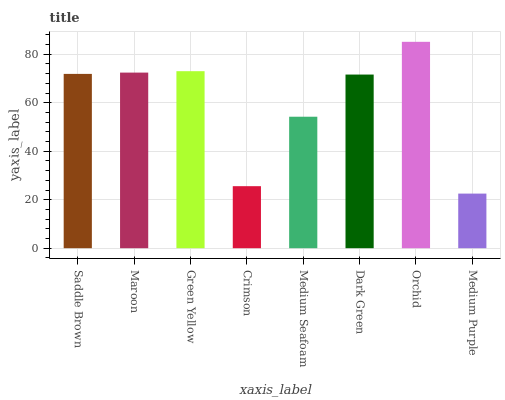Is Medium Purple the minimum?
Answer yes or no. Yes. Is Orchid the maximum?
Answer yes or no. Yes. Is Maroon the minimum?
Answer yes or no. No. Is Maroon the maximum?
Answer yes or no. No. Is Maroon greater than Saddle Brown?
Answer yes or no. Yes. Is Saddle Brown less than Maroon?
Answer yes or no. Yes. Is Saddle Brown greater than Maroon?
Answer yes or no. No. Is Maroon less than Saddle Brown?
Answer yes or no. No. Is Saddle Brown the high median?
Answer yes or no. Yes. Is Dark Green the low median?
Answer yes or no. Yes. Is Dark Green the high median?
Answer yes or no. No. Is Saddle Brown the low median?
Answer yes or no. No. 